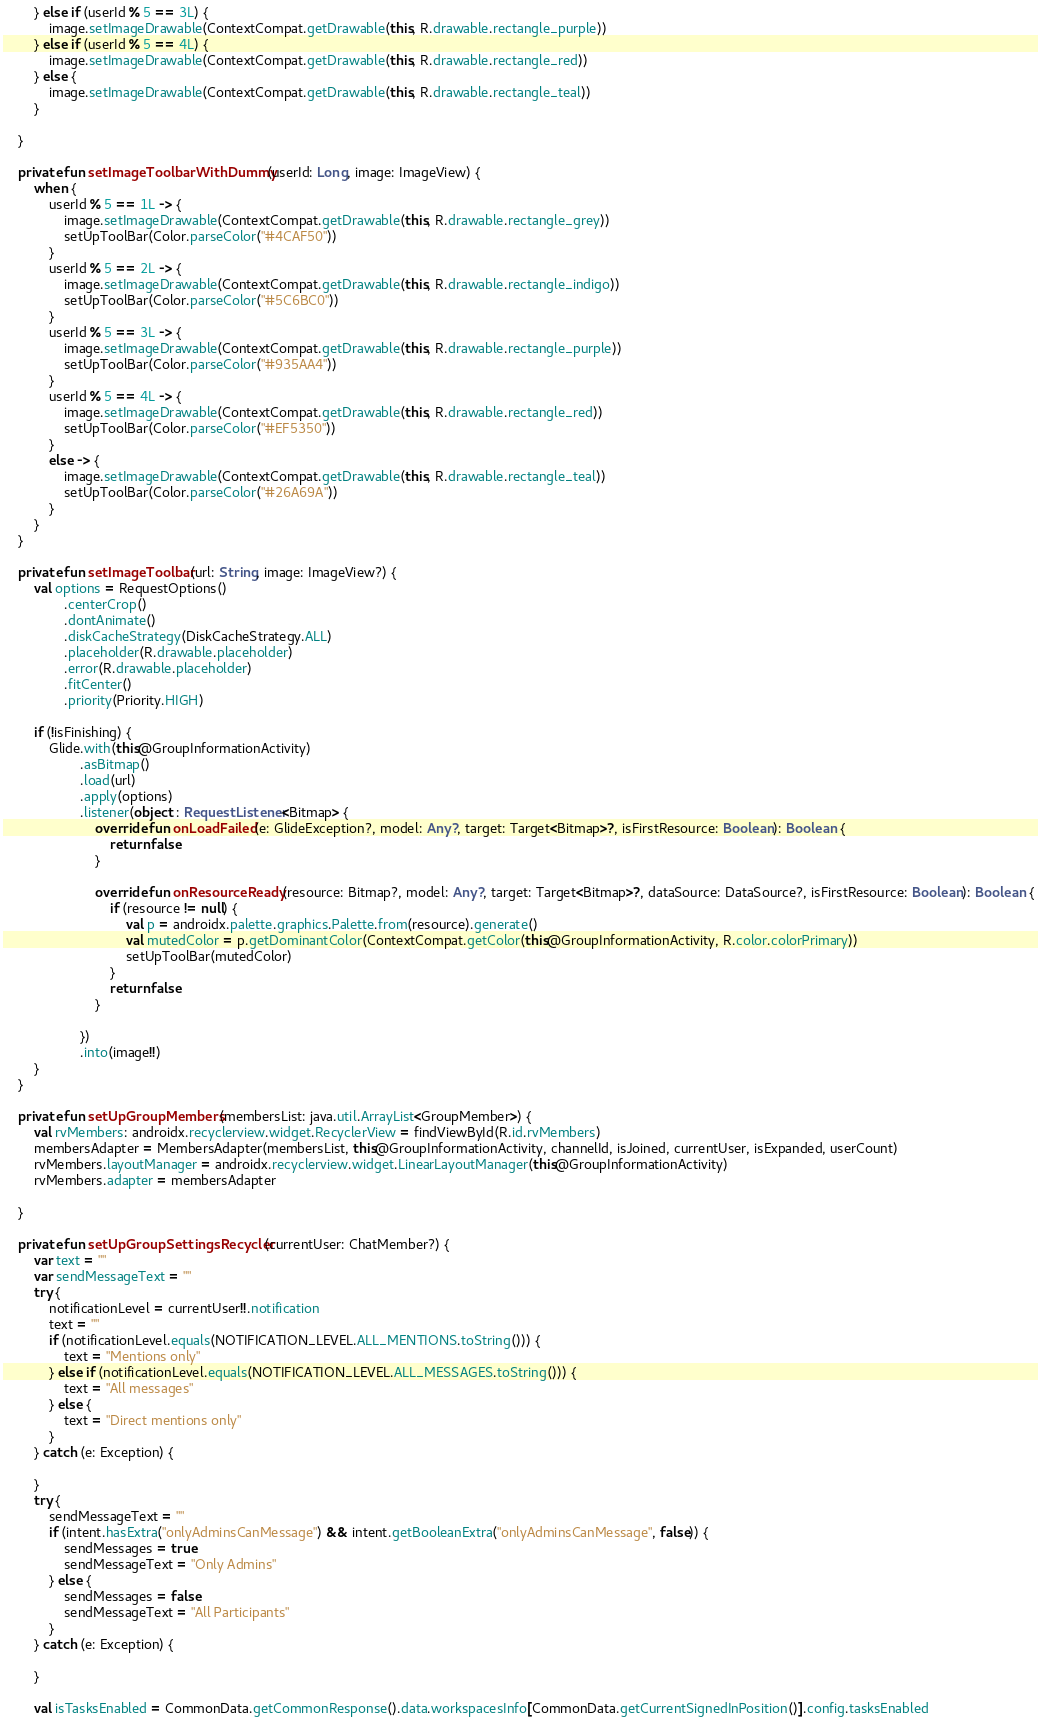Convert code to text. <code><loc_0><loc_0><loc_500><loc_500><_Kotlin_>        } else if (userId % 5 == 3L) {
            image.setImageDrawable(ContextCompat.getDrawable(this, R.drawable.rectangle_purple))
        } else if (userId % 5 == 4L) {
            image.setImageDrawable(ContextCompat.getDrawable(this, R.drawable.rectangle_red))
        } else {
            image.setImageDrawable(ContextCompat.getDrawable(this, R.drawable.rectangle_teal))
        }

    }

    private fun setImageToolbarWithDummy(userId: Long, image: ImageView) {
        when {
            userId % 5 == 1L -> {
                image.setImageDrawable(ContextCompat.getDrawable(this, R.drawable.rectangle_grey))
                setUpToolBar(Color.parseColor("#4CAF50"))
            }
            userId % 5 == 2L -> {
                image.setImageDrawable(ContextCompat.getDrawable(this, R.drawable.rectangle_indigo))
                setUpToolBar(Color.parseColor("#5C6BC0"))
            }
            userId % 5 == 3L -> {
                image.setImageDrawable(ContextCompat.getDrawable(this, R.drawable.rectangle_purple))
                setUpToolBar(Color.parseColor("#935AA4"))
            }
            userId % 5 == 4L -> {
                image.setImageDrawable(ContextCompat.getDrawable(this, R.drawable.rectangle_red))
                setUpToolBar(Color.parseColor("#EF5350"))
            }
            else -> {
                image.setImageDrawable(ContextCompat.getDrawable(this, R.drawable.rectangle_teal))
                setUpToolBar(Color.parseColor("#26A69A"))
            }
        }
    }

    private fun setImageToolbar(url: String, image: ImageView?) {
        val options = RequestOptions()
                .centerCrop()
                .dontAnimate()
                .diskCacheStrategy(DiskCacheStrategy.ALL)
                .placeholder(R.drawable.placeholder)
                .error(R.drawable.placeholder)
                .fitCenter()
                .priority(Priority.HIGH)

        if (!isFinishing) {
            Glide.with(this@GroupInformationActivity)
                    .asBitmap()
                    .load(url)
                    .apply(options)
                    .listener(object : RequestListener<Bitmap> {
                        override fun onLoadFailed(e: GlideException?, model: Any?, target: Target<Bitmap>?, isFirstResource: Boolean): Boolean {
                            return false
                        }

                        override fun onResourceReady(resource: Bitmap?, model: Any?, target: Target<Bitmap>?, dataSource: DataSource?, isFirstResource: Boolean): Boolean {
                            if (resource != null) {
                                val p = androidx.palette.graphics.Palette.from(resource).generate()
                                val mutedColor = p.getDominantColor(ContextCompat.getColor(this@GroupInformationActivity, R.color.colorPrimary))
                                setUpToolBar(mutedColor)
                            }
                            return false
                        }

                    })
                    .into(image!!)
        }
    }

    private fun setUpGroupMembers(membersList: java.util.ArrayList<GroupMember>) {
        val rvMembers: androidx.recyclerview.widget.RecyclerView = findViewById(R.id.rvMembers)
        membersAdapter = MembersAdapter(membersList, this@GroupInformationActivity, channelId, isJoined, currentUser, isExpanded, userCount)
        rvMembers.layoutManager = androidx.recyclerview.widget.LinearLayoutManager(this@GroupInformationActivity)
        rvMembers.adapter = membersAdapter

    }

    private fun setUpGroupSettingsRecycler(currentUser: ChatMember?) {
        var text = ""
        var sendMessageText = ""
        try {
            notificationLevel = currentUser!!.notification
            text = ""
            if (notificationLevel.equals(NOTIFICATION_LEVEL.ALL_MENTIONS.toString())) {
                text = "Mentions only"
            } else if (notificationLevel.equals(NOTIFICATION_LEVEL.ALL_MESSAGES.toString())) {
                text = "All messages"
            } else {
                text = "Direct mentions only"
            }
        } catch (e: Exception) {

        }
        try {
            sendMessageText = ""
            if (intent.hasExtra("onlyAdminsCanMessage") && intent.getBooleanExtra("onlyAdminsCanMessage", false)) {
                sendMessages = true
                sendMessageText = "Only Admins"
            } else {
                sendMessages = false
                sendMessageText = "All Participants"
            }
        } catch (e: Exception) {

        }

        val isTasksEnabled = CommonData.getCommonResponse().data.workspacesInfo[CommonData.getCurrentSignedInPosition()].config.tasksEnabled</code> 